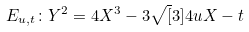<formula> <loc_0><loc_0><loc_500><loc_500>E _ { u , t } \colon Y ^ { 2 } = 4 X ^ { 3 } - 3 { \sqrt { [ } 3 ] { 4 } } u X - t</formula> 